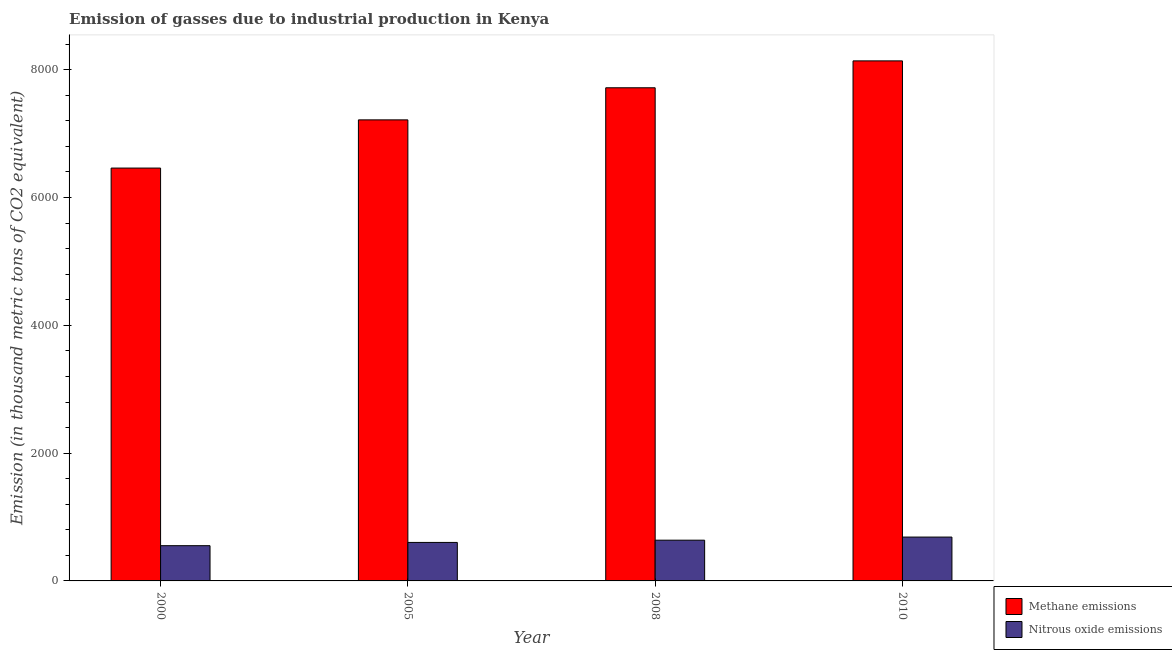How many different coloured bars are there?
Ensure brevity in your answer.  2. Are the number of bars per tick equal to the number of legend labels?
Your answer should be very brief. Yes. How many bars are there on the 4th tick from the left?
Offer a terse response. 2. In how many cases, is the number of bars for a given year not equal to the number of legend labels?
Your answer should be compact. 0. What is the amount of nitrous oxide emissions in 2010?
Ensure brevity in your answer.  686.4. Across all years, what is the maximum amount of nitrous oxide emissions?
Keep it short and to the point. 686.4. Across all years, what is the minimum amount of methane emissions?
Your answer should be compact. 6461.4. In which year was the amount of methane emissions maximum?
Ensure brevity in your answer.  2010. What is the total amount of nitrous oxide emissions in the graph?
Offer a very short reply. 2478. What is the difference between the amount of nitrous oxide emissions in 2000 and that in 2010?
Your answer should be compact. -134.9. What is the difference between the amount of methane emissions in 2000 and the amount of nitrous oxide emissions in 2005?
Ensure brevity in your answer.  -754.5. What is the average amount of nitrous oxide emissions per year?
Make the answer very short. 619.5. What is the ratio of the amount of methane emissions in 2000 to that in 2008?
Provide a succinct answer. 0.84. Is the amount of methane emissions in 2005 less than that in 2008?
Offer a very short reply. Yes. Is the difference between the amount of methane emissions in 2000 and 2008 greater than the difference between the amount of nitrous oxide emissions in 2000 and 2008?
Your answer should be very brief. No. What is the difference between the highest and the second highest amount of methane emissions?
Your answer should be compact. 421. What is the difference between the highest and the lowest amount of methane emissions?
Make the answer very short. 1677.7. In how many years, is the amount of nitrous oxide emissions greater than the average amount of nitrous oxide emissions taken over all years?
Offer a terse response. 2. What does the 1st bar from the left in 2008 represents?
Offer a very short reply. Methane emissions. What does the 1st bar from the right in 2000 represents?
Keep it short and to the point. Nitrous oxide emissions. How many years are there in the graph?
Your answer should be very brief. 4. What is the difference between two consecutive major ticks on the Y-axis?
Make the answer very short. 2000. Does the graph contain grids?
Offer a very short reply. No. How are the legend labels stacked?
Offer a terse response. Vertical. What is the title of the graph?
Offer a very short reply. Emission of gasses due to industrial production in Kenya. Does "Male labor force" appear as one of the legend labels in the graph?
Give a very brief answer. No. What is the label or title of the X-axis?
Your answer should be very brief. Year. What is the label or title of the Y-axis?
Give a very brief answer. Emission (in thousand metric tons of CO2 equivalent). What is the Emission (in thousand metric tons of CO2 equivalent) in Methane emissions in 2000?
Offer a very short reply. 6461.4. What is the Emission (in thousand metric tons of CO2 equivalent) of Nitrous oxide emissions in 2000?
Offer a terse response. 551.5. What is the Emission (in thousand metric tons of CO2 equivalent) in Methane emissions in 2005?
Offer a very short reply. 7215.9. What is the Emission (in thousand metric tons of CO2 equivalent) of Nitrous oxide emissions in 2005?
Provide a short and direct response. 602.4. What is the Emission (in thousand metric tons of CO2 equivalent) in Methane emissions in 2008?
Keep it short and to the point. 7718.1. What is the Emission (in thousand metric tons of CO2 equivalent) in Nitrous oxide emissions in 2008?
Give a very brief answer. 637.7. What is the Emission (in thousand metric tons of CO2 equivalent) of Methane emissions in 2010?
Make the answer very short. 8139.1. What is the Emission (in thousand metric tons of CO2 equivalent) of Nitrous oxide emissions in 2010?
Offer a very short reply. 686.4. Across all years, what is the maximum Emission (in thousand metric tons of CO2 equivalent) of Methane emissions?
Your answer should be compact. 8139.1. Across all years, what is the maximum Emission (in thousand metric tons of CO2 equivalent) in Nitrous oxide emissions?
Keep it short and to the point. 686.4. Across all years, what is the minimum Emission (in thousand metric tons of CO2 equivalent) in Methane emissions?
Ensure brevity in your answer.  6461.4. Across all years, what is the minimum Emission (in thousand metric tons of CO2 equivalent) in Nitrous oxide emissions?
Keep it short and to the point. 551.5. What is the total Emission (in thousand metric tons of CO2 equivalent) of Methane emissions in the graph?
Offer a terse response. 2.95e+04. What is the total Emission (in thousand metric tons of CO2 equivalent) in Nitrous oxide emissions in the graph?
Make the answer very short. 2478. What is the difference between the Emission (in thousand metric tons of CO2 equivalent) of Methane emissions in 2000 and that in 2005?
Make the answer very short. -754.5. What is the difference between the Emission (in thousand metric tons of CO2 equivalent) in Nitrous oxide emissions in 2000 and that in 2005?
Offer a terse response. -50.9. What is the difference between the Emission (in thousand metric tons of CO2 equivalent) of Methane emissions in 2000 and that in 2008?
Give a very brief answer. -1256.7. What is the difference between the Emission (in thousand metric tons of CO2 equivalent) in Nitrous oxide emissions in 2000 and that in 2008?
Keep it short and to the point. -86.2. What is the difference between the Emission (in thousand metric tons of CO2 equivalent) in Methane emissions in 2000 and that in 2010?
Keep it short and to the point. -1677.7. What is the difference between the Emission (in thousand metric tons of CO2 equivalent) of Nitrous oxide emissions in 2000 and that in 2010?
Provide a short and direct response. -134.9. What is the difference between the Emission (in thousand metric tons of CO2 equivalent) of Methane emissions in 2005 and that in 2008?
Your answer should be very brief. -502.2. What is the difference between the Emission (in thousand metric tons of CO2 equivalent) of Nitrous oxide emissions in 2005 and that in 2008?
Offer a terse response. -35.3. What is the difference between the Emission (in thousand metric tons of CO2 equivalent) in Methane emissions in 2005 and that in 2010?
Ensure brevity in your answer.  -923.2. What is the difference between the Emission (in thousand metric tons of CO2 equivalent) in Nitrous oxide emissions in 2005 and that in 2010?
Provide a short and direct response. -84. What is the difference between the Emission (in thousand metric tons of CO2 equivalent) of Methane emissions in 2008 and that in 2010?
Ensure brevity in your answer.  -421. What is the difference between the Emission (in thousand metric tons of CO2 equivalent) in Nitrous oxide emissions in 2008 and that in 2010?
Offer a terse response. -48.7. What is the difference between the Emission (in thousand metric tons of CO2 equivalent) of Methane emissions in 2000 and the Emission (in thousand metric tons of CO2 equivalent) of Nitrous oxide emissions in 2005?
Provide a succinct answer. 5859. What is the difference between the Emission (in thousand metric tons of CO2 equivalent) of Methane emissions in 2000 and the Emission (in thousand metric tons of CO2 equivalent) of Nitrous oxide emissions in 2008?
Offer a very short reply. 5823.7. What is the difference between the Emission (in thousand metric tons of CO2 equivalent) of Methane emissions in 2000 and the Emission (in thousand metric tons of CO2 equivalent) of Nitrous oxide emissions in 2010?
Keep it short and to the point. 5775. What is the difference between the Emission (in thousand metric tons of CO2 equivalent) of Methane emissions in 2005 and the Emission (in thousand metric tons of CO2 equivalent) of Nitrous oxide emissions in 2008?
Ensure brevity in your answer.  6578.2. What is the difference between the Emission (in thousand metric tons of CO2 equivalent) in Methane emissions in 2005 and the Emission (in thousand metric tons of CO2 equivalent) in Nitrous oxide emissions in 2010?
Offer a terse response. 6529.5. What is the difference between the Emission (in thousand metric tons of CO2 equivalent) of Methane emissions in 2008 and the Emission (in thousand metric tons of CO2 equivalent) of Nitrous oxide emissions in 2010?
Your answer should be compact. 7031.7. What is the average Emission (in thousand metric tons of CO2 equivalent) in Methane emissions per year?
Your answer should be very brief. 7383.62. What is the average Emission (in thousand metric tons of CO2 equivalent) in Nitrous oxide emissions per year?
Ensure brevity in your answer.  619.5. In the year 2000, what is the difference between the Emission (in thousand metric tons of CO2 equivalent) of Methane emissions and Emission (in thousand metric tons of CO2 equivalent) of Nitrous oxide emissions?
Your response must be concise. 5909.9. In the year 2005, what is the difference between the Emission (in thousand metric tons of CO2 equivalent) in Methane emissions and Emission (in thousand metric tons of CO2 equivalent) in Nitrous oxide emissions?
Offer a terse response. 6613.5. In the year 2008, what is the difference between the Emission (in thousand metric tons of CO2 equivalent) of Methane emissions and Emission (in thousand metric tons of CO2 equivalent) of Nitrous oxide emissions?
Your response must be concise. 7080.4. In the year 2010, what is the difference between the Emission (in thousand metric tons of CO2 equivalent) in Methane emissions and Emission (in thousand metric tons of CO2 equivalent) in Nitrous oxide emissions?
Make the answer very short. 7452.7. What is the ratio of the Emission (in thousand metric tons of CO2 equivalent) of Methane emissions in 2000 to that in 2005?
Your response must be concise. 0.9. What is the ratio of the Emission (in thousand metric tons of CO2 equivalent) of Nitrous oxide emissions in 2000 to that in 2005?
Make the answer very short. 0.92. What is the ratio of the Emission (in thousand metric tons of CO2 equivalent) of Methane emissions in 2000 to that in 2008?
Give a very brief answer. 0.84. What is the ratio of the Emission (in thousand metric tons of CO2 equivalent) in Nitrous oxide emissions in 2000 to that in 2008?
Ensure brevity in your answer.  0.86. What is the ratio of the Emission (in thousand metric tons of CO2 equivalent) in Methane emissions in 2000 to that in 2010?
Provide a short and direct response. 0.79. What is the ratio of the Emission (in thousand metric tons of CO2 equivalent) of Nitrous oxide emissions in 2000 to that in 2010?
Keep it short and to the point. 0.8. What is the ratio of the Emission (in thousand metric tons of CO2 equivalent) of Methane emissions in 2005 to that in 2008?
Make the answer very short. 0.93. What is the ratio of the Emission (in thousand metric tons of CO2 equivalent) of Nitrous oxide emissions in 2005 to that in 2008?
Ensure brevity in your answer.  0.94. What is the ratio of the Emission (in thousand metric tons of CO2 equivalent) of Methane emissions in 2005 to that in 2010?
Offer a very short reply. 0.89. What is the ratio of the Emission (in thousand metric tons of CO2 equivalent) of Nitrous oxide emissions in 2005 to that in 2010?
Offer a very short reply. 0.88. What is the ratio of the Emission (in thousand metric tons of CO2 equivalent) of Methane emissions in 2008 to that in 2010?
Provide a succinct answer. 0.95. What is the ratio of the Emission (in thousand metric tons of CO2 equivalent) in Nitrous oxide emissions in 2008 to that in 2010?
Your response must be concise. 0.93. What is the difference between the highest and the second highest Emission (in thousand metric tons of CO2 equivalent) in Methane emissions?
Provide a short and direct response. 421. What is the difference between the highest and the second highest Emission (in thousand metric tons of CO2 equivalent) of Nitrous oxide emissions?
Offer a terse response. 48.7. What is the difference between the highest and the lowest Emission (in thousand metric tons of CO2 equivalent) of Methane emissions?
Provide a short and direct response. 1677.7. What is the difference between the highest and the lowest Emission (in thousand metric tons of CO2 equivalent) in Nitrous oxide emissions?
Provide a succinct answer. 134.9. 